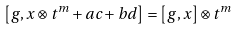<formula> <loc_0><loc_0><loc_500><loc_500>\left [ g , x \otimes t ^ { m } + a c + b d \right ] = \left [ g , x \right ] \otimes t ^ { m }</formula> 